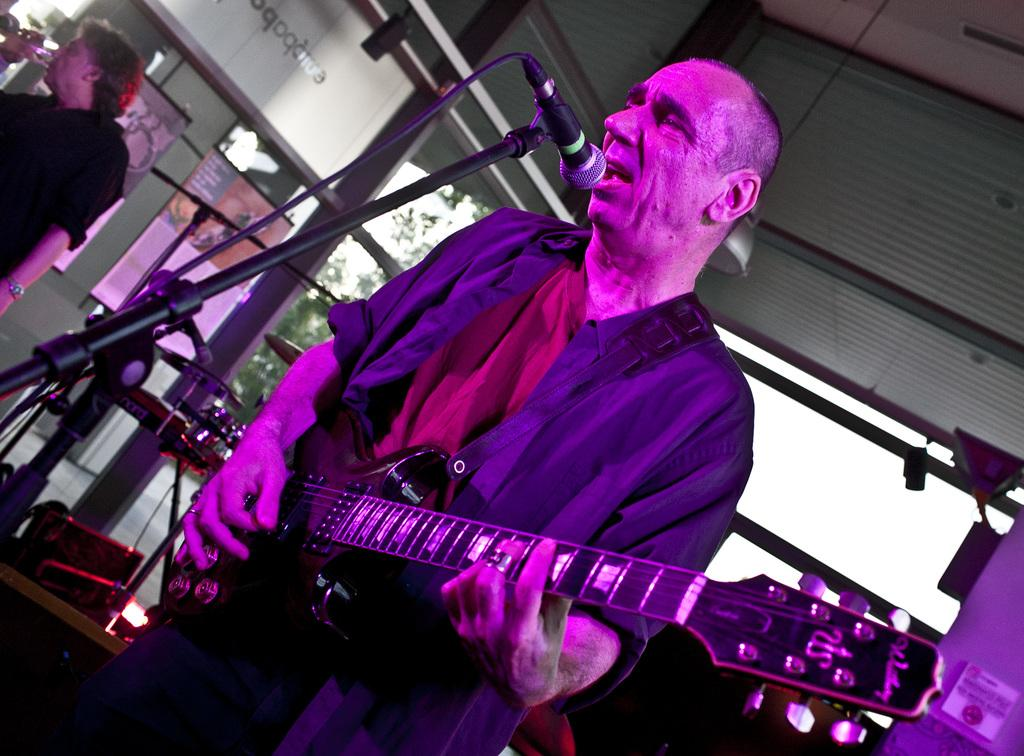What is the person on the left side of the image holding? The person on the left side of the image is holding a guitar. What object is present for amplifying sound in the image? There is a microphone in the image. What is the person on the right side of the image holding? The person on the right side of the image is holding a glass. What type of vegetation can be seen in the image? There are trees visible in the image. What is the purpose of the stand in the image? The stand in the image is likely used to hold the microphone or other equipment. What type of stone is used to create the base of the microphone in the image? There is no stone mentioned or visible in the image; the microphone is not described as having a base. 